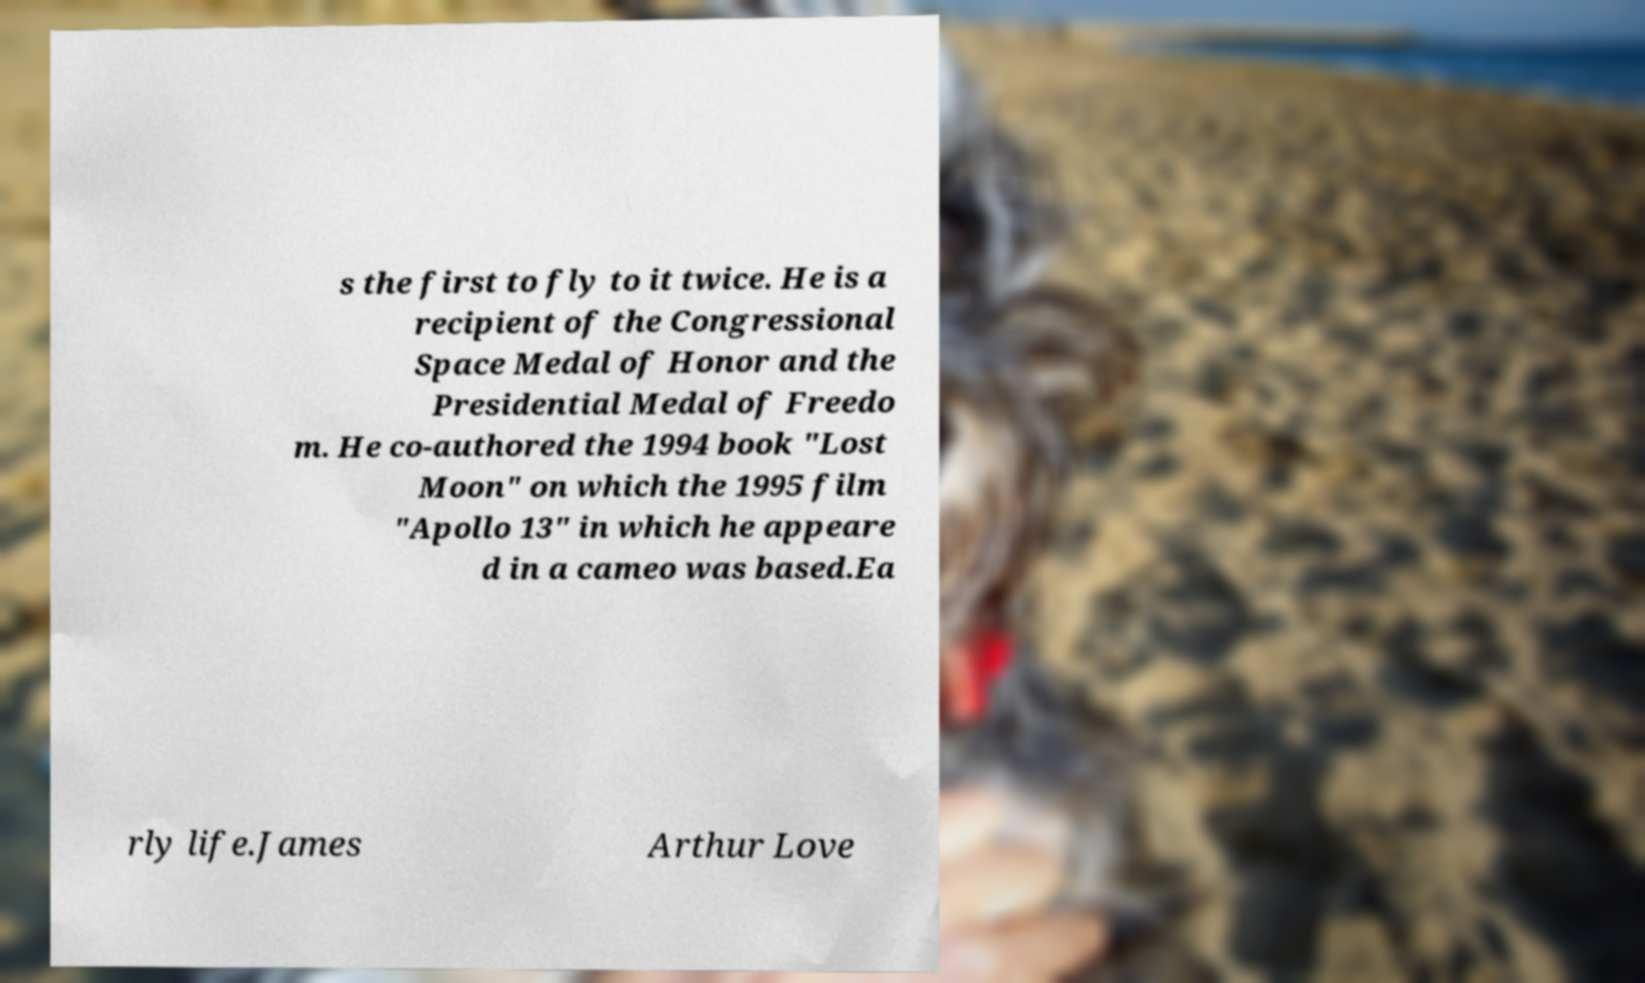For documentation purposes, I need the text within this image transcribed. Could you provide that? s the first to fly to it twice. He is a recipient of the Congressional Space Medal of Honor and the Presidential Medal of Freedo m. He co-authored the 1994 book "Lost Moon" on which the 1995 film "Apollo 13" in which he appeare d in a cameo was based.Ea rly life.James Arthur Love 